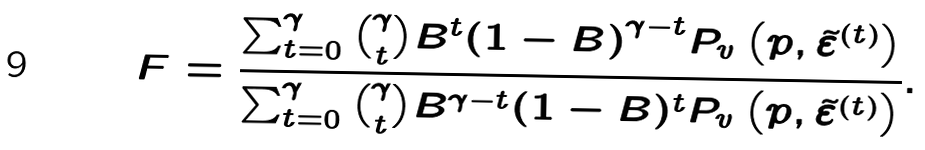<formula> <loc_0><loc_0><loc_500><loc_500>F = \frac { \sum _ { t = 0 } ^ { \gamma } \binom { \gamma } { t } B ^ { t } { ( 1 - B ) } ^ { \gamma - t } P _ { v } \left ( p , \tilde { \varepsilon } ^ { ( t ) } \right ) } { \sum _ { t = 0 } ^ { \gamma } \binom { \gamma } { t } { B } ^ { \gamma - t } ( 1 - B ) ^ { t } P _ { v } \left ( p , \tilde { \varepsilon } ^ { ( t ) } \right ) } .</formula> 